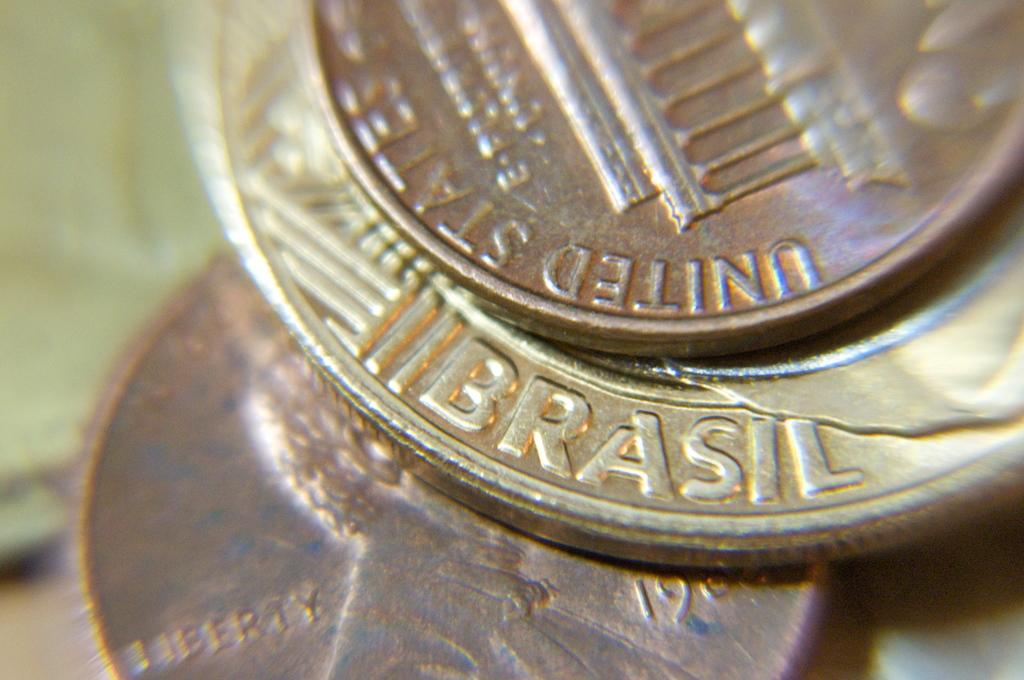Provide a one-sentence caption for the provided image. A stack of American and Brazillian coins up close, one of the coins says Brazil at the bottom. 